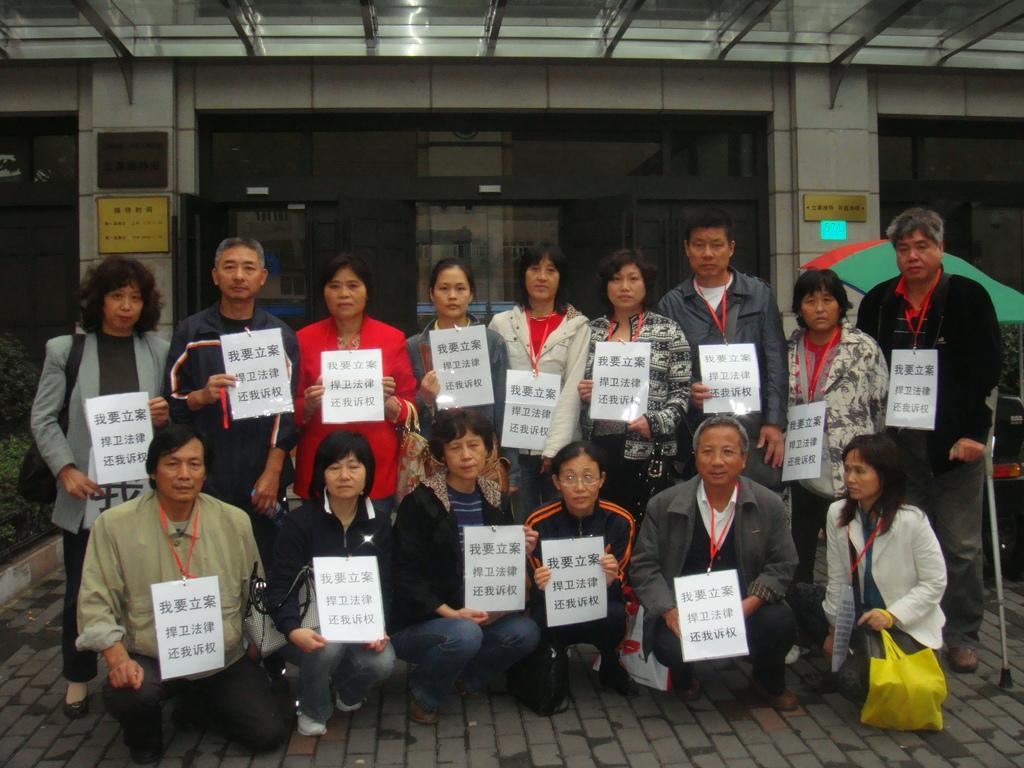Could you give a brief overview of what you see in this image? In this picture I can see there are a group of people, few of them are standing and few are sitting on the floor. They are wearing few boards in neck and in the backdrop there is a building and it has glass doors. There is a woman at right side, she is holding a yellow cover. 